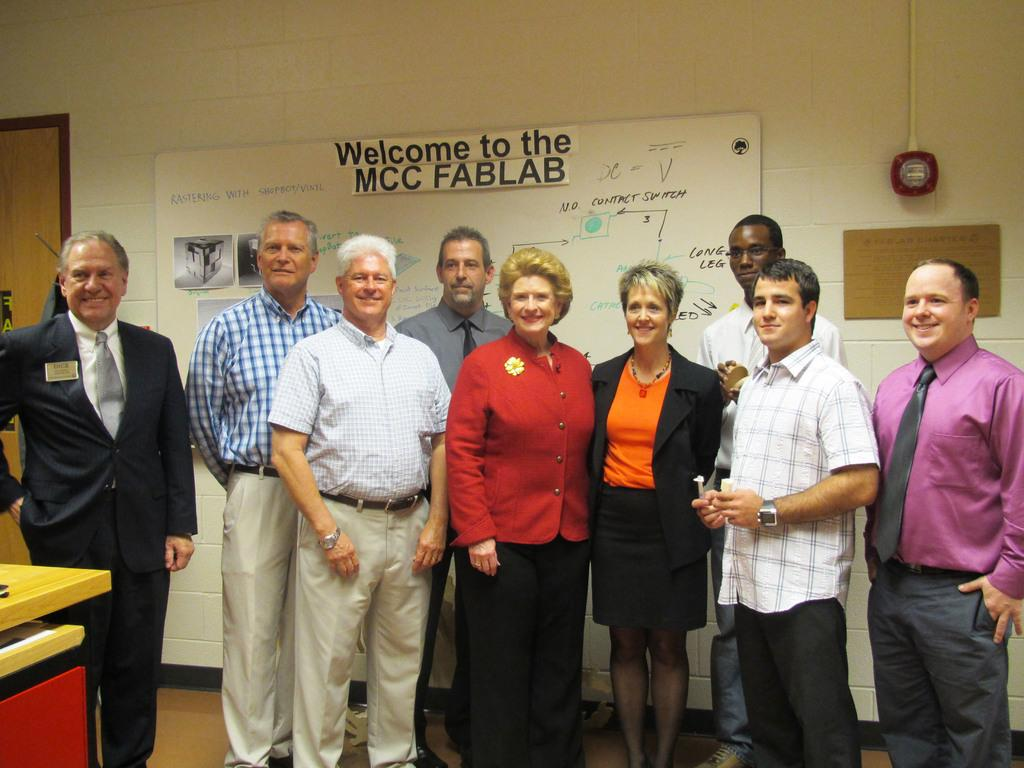What are the people in the image doing? The persons in the image are standing and posing for a photograph. What can be seen in the background of the image? There is a wall, a screen, and a door in the background of the image. What type of duck can be seen sitting on the cactus in the image? There is no duck or cactus present in the image. How is the whip being used in the image? There is no whip present in the image. 